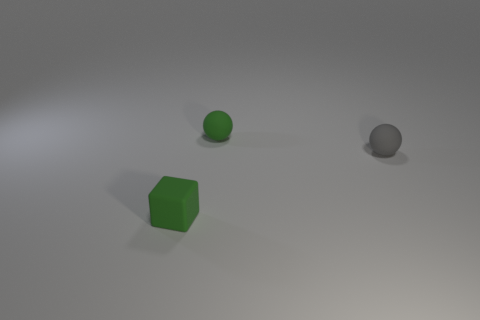Add 1 big shiny spheres. How many objects exist? 4 Subtract all blocks. How many objects are left? 2 Subtract all big cyan metal blocks. Subtract all blocks. How many objects are left? 2 Add 3 spheres. How many spheres are left? 5 Add 3 large rubber spheres. How many large rubber spheres exist? 3 Subtract 0 brown blocks. How many objects are left? 3 